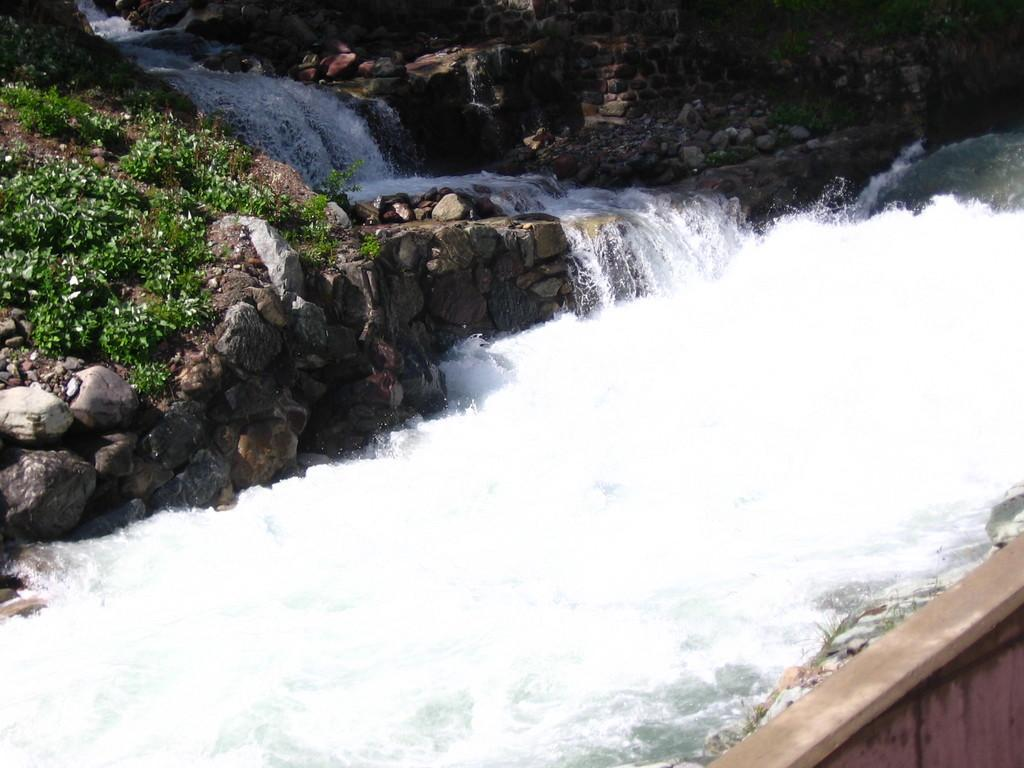What is the primary element visible in the image? There is water in the image. What can be found near the water? There are stones beside the water. What is growing on top of the stones? There are plants on top of the stones. How is the water moving in the image? Water is flowing from the rocks. Can you see the writer holding a horn while drinking eggnog in the image? There is no writer, horn, or eggnog present in the image. 